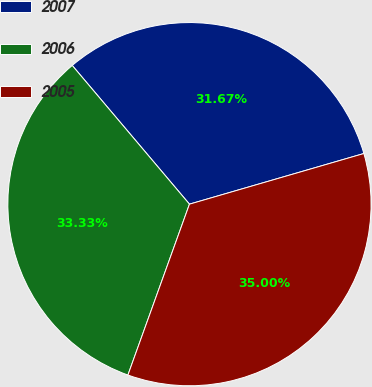Convert chart. <chart><loc_0><loc_0><loc_500><loc_500><pie_chart><fcel>2007<fcel>2006<fcel>2005<nl><fcel>31.67%<fcel>33.33%<fcel>35.0%<nl></chart> 